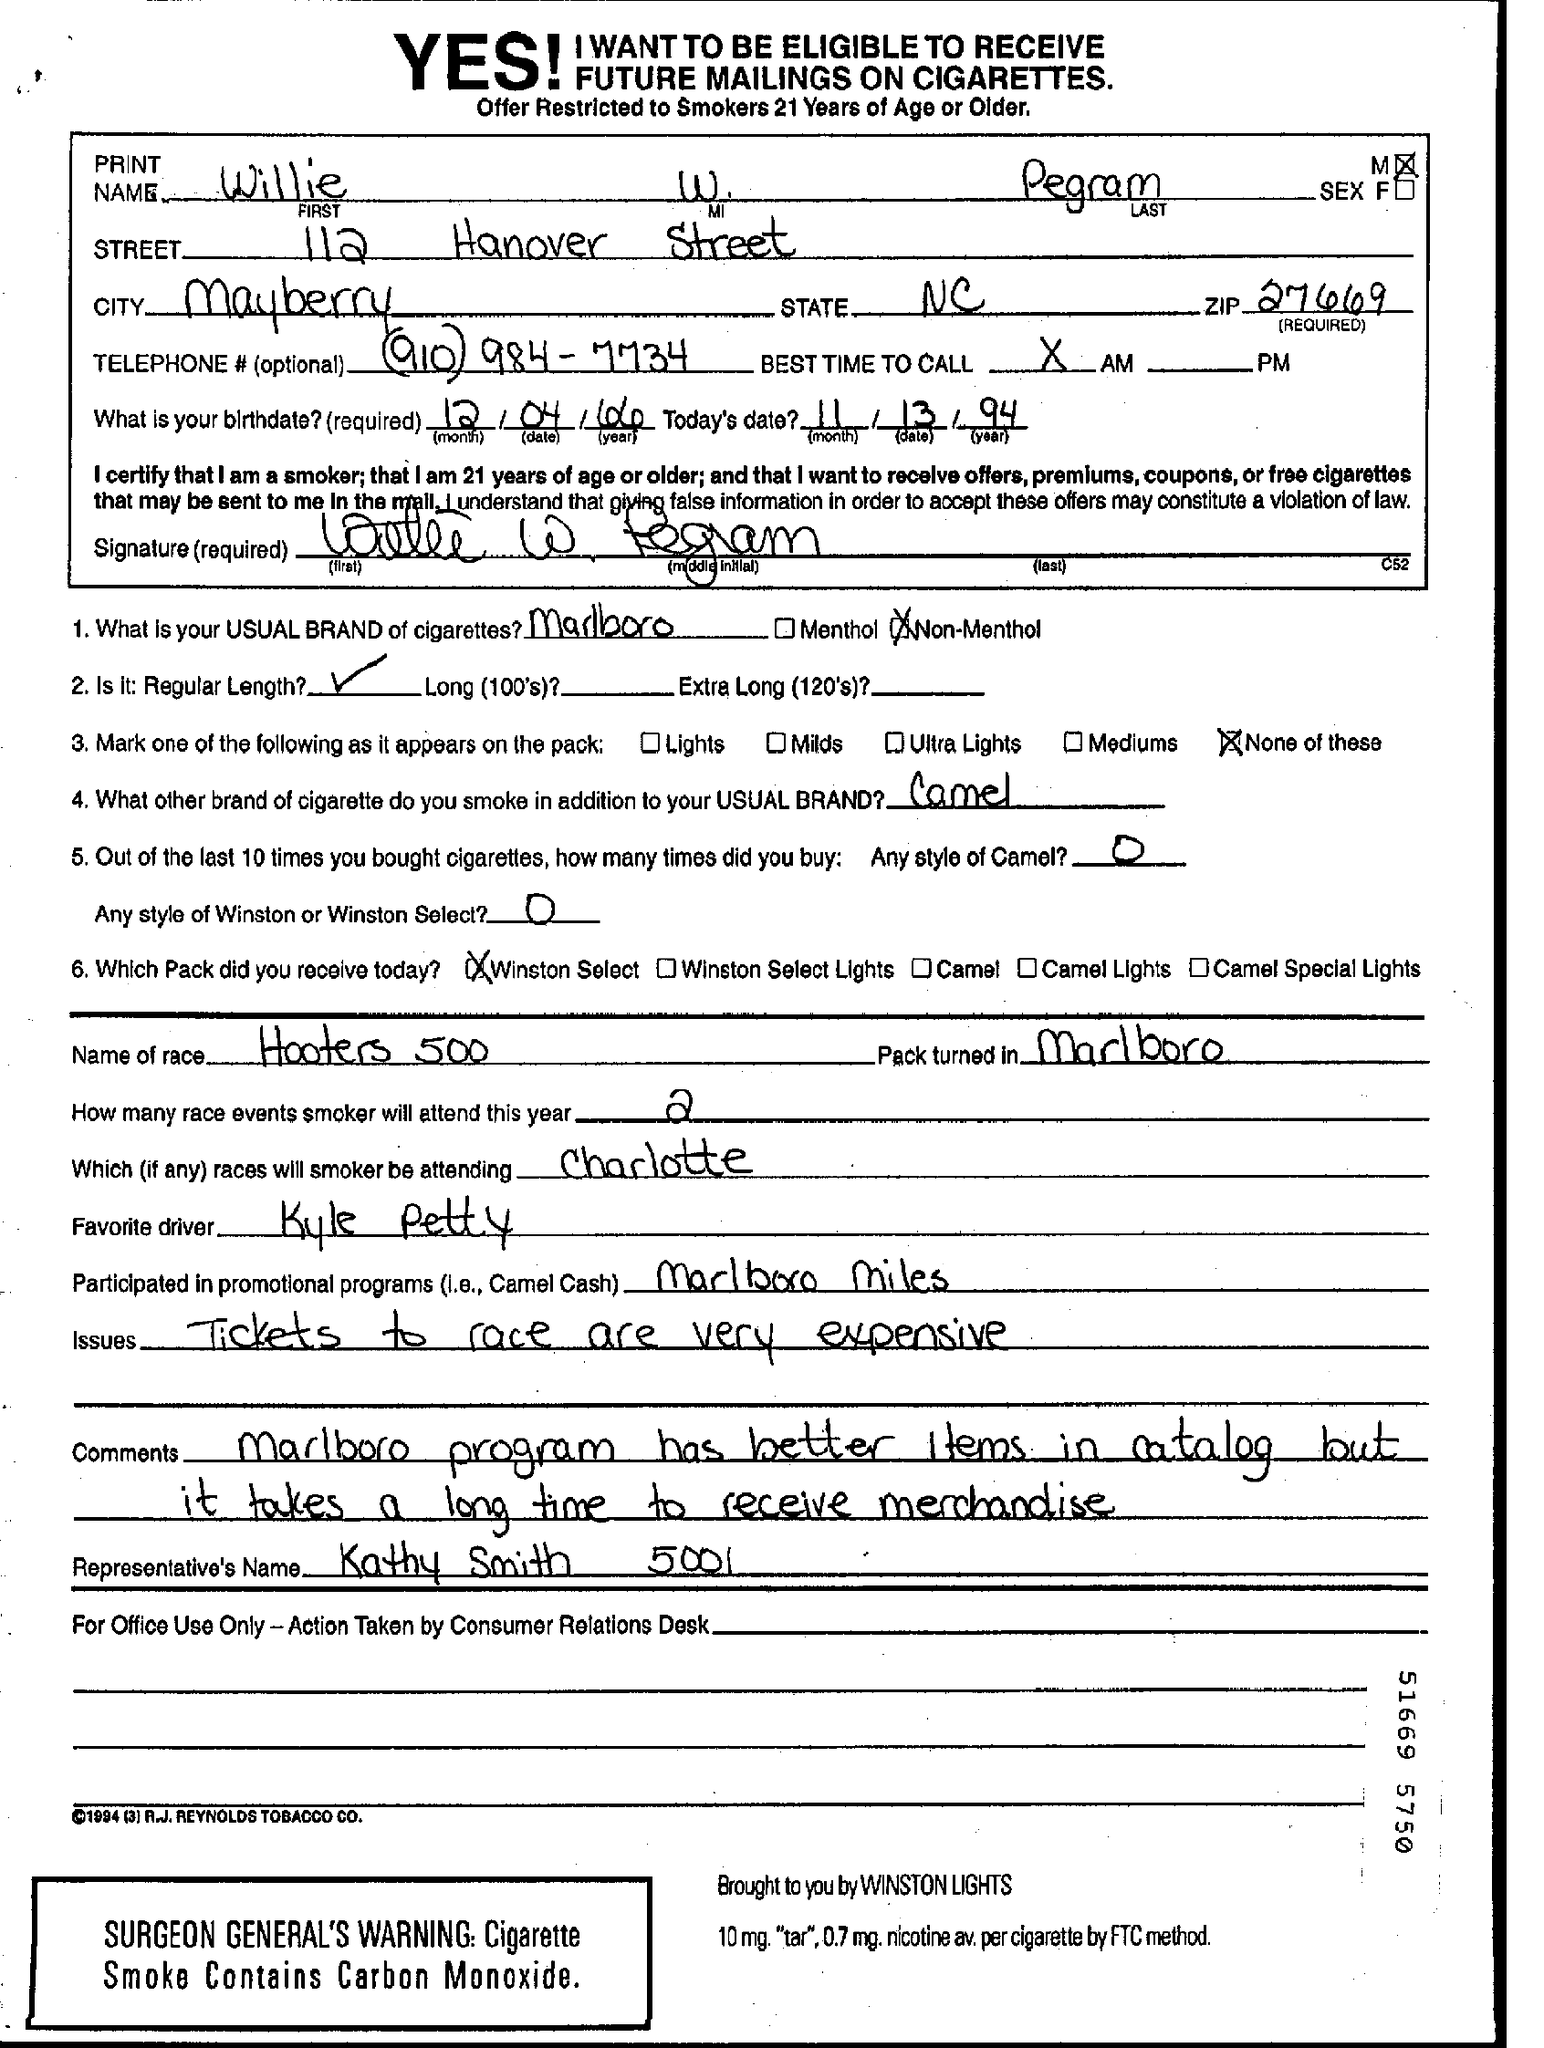Specify some key components in this picture. Kyle Petty is the favorite driver among many people. What is the ZIP code for 27669..?" is a question that seeks information on the ZIP code assigned to a specific geographical region. The telephone number is (910) 984-7734. The last name is Pegram. What is the City?" is a question that is being asked, and in response, someone is mentioning the idea of Mayberry as a comparison. 